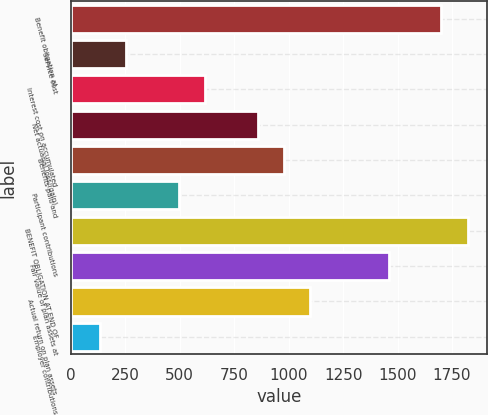<chart> <loc_0><loc_0><loc_500><loc_500><bar_chart><fcel>Benefit obligation at<fcel>Service cost<fcel>Interest cost on accumulated<fcel>Net actuarial loss/(gain)<fcel>Benefits paid and<fcel>Participant contributions<fcel>BENEFIT OBLIGATION AT END OF<fcel>Fair value of plan assets at<fcel>Actual return on plan assets<fcel>Employer contributions<nl><fcel>1701<fcel>255<fcel>616.5<fcel>857.5<fcel>978<fcel>496<fcel>1821.5<fcel>1460<fcel>1098.5<fcel>134.5<nl></chart> 